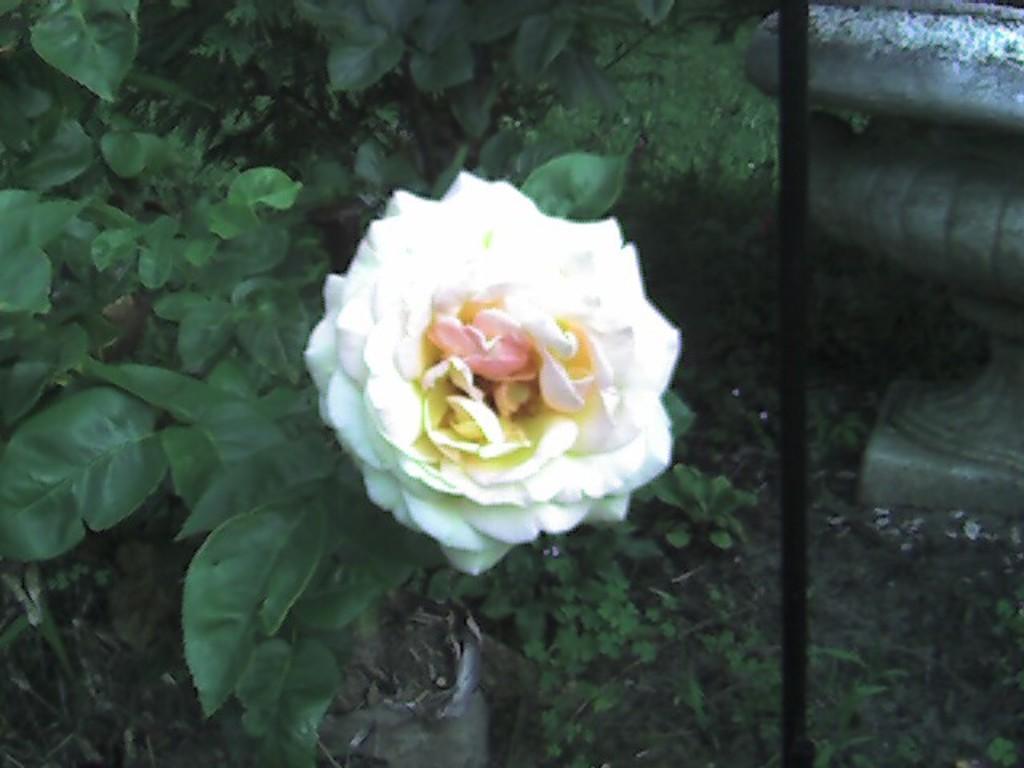Could you give a brief overview of what you see in this image? This is a zoomed in picture. In the center there is a white color flower and we can see the plants. In the background there is a black color metal rod and some other object and the green grass. 